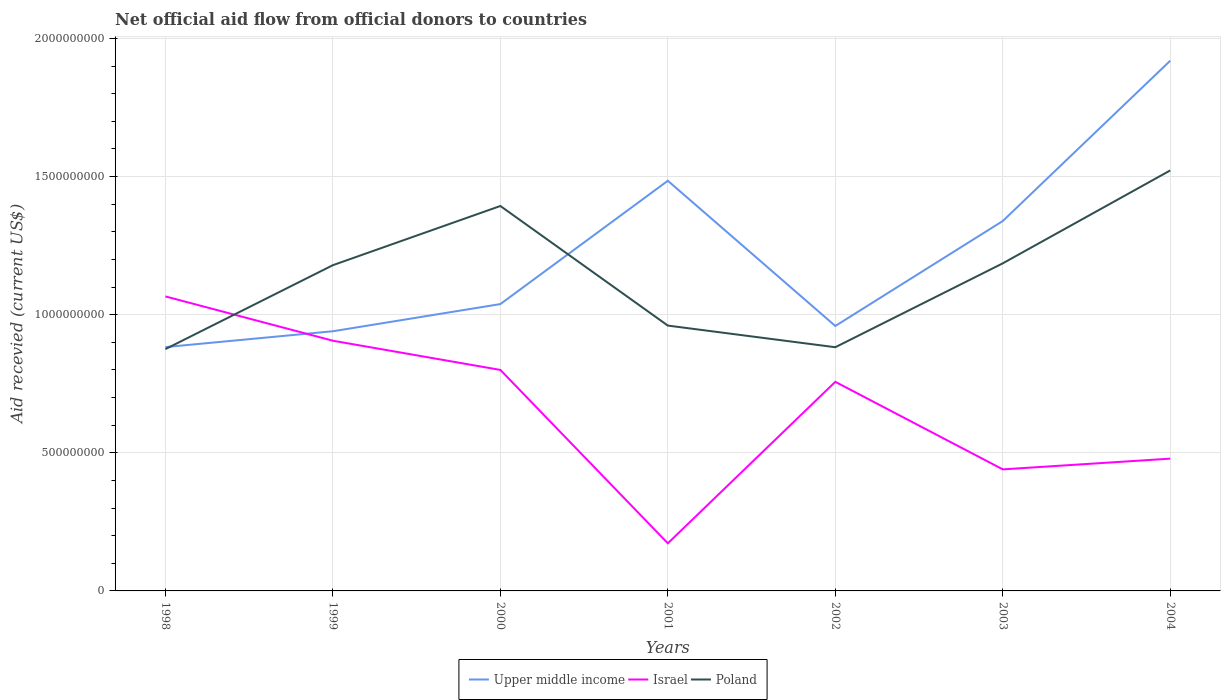Across all years, what is the maximum total aid received in Upper middle income?
Your answer should be very brief. 8.83e+08. What is the total total aid received in Upper middle income in the graph?
Provide a succinct answer. 1.46e+08. What is the difference between the highest and the second highest total aid received in Upper middle income?
Ensure brevity in your answer.  1.04e+09. Is the total aid received in Israel strictly greater than the total aid received in Upper middle income over the years?
Offer a terse response. No. What is the difference between two consecutive major ticks on the Y-axis?
Your response must be concise. 5.00e+08. Are the values on the major ticks of Y-axis written in scientific E-notation?
Make the answer very short. No. Does the graph contain grids?
Make the answer very short. Yes. Where does the legend appear in the graph?
Make the answer very short. Bottom center. How are the legend labels stacked?
Provide a short and direct response. Horizontal. What is the title of the graph?
Your answer should be very brief. Net official aid flow from official donors to countries. What is the label or title of the Y-axis?
Give a very brief answer. Aid recevied (current US$). What is the Aid recevied (current US$) in Upper middle income in 1998?
Your answer should be compact. 8.83e+08. What is the Aid recevied (current US$) of Israel in 1998?
Your response must be concise. 1.07e+09. What is the Aid recevied (current US$) in Poland in 1998?
Ensure brevity in your answer.  8.75e+08. What is the Aid recevied (current US$) in Upper middle income in 1999?
Give a very brief answer. 9.40e+08. What is the Aid recevied (current US$) of Israel in 1999?
Ensure brevity in your answer.  9.06e+08. What is the Aid recevied (current US$) in Poland in 1999?
Give a very brief answer. 1.18e+09. What is the Aid recevied (current US$) of Upper middle income in 2000?
Provide a short and direct response. 1.04e+09. What is the Aid recevied (current US$) of Israel in 2000?
Offer a terse response. 8.00e+08. What is the Aid recevied (current US$) of Poland in 2000?
Make the answer very short. 1.39e+09. What is the Aid recevied (current US$) in Upper middle income in 2001?
Your response must be concise. 1.48e+09. What is the Aid recevied (current US$) in Israel in 2001?
Provide a succinct answer. 1.72e+08. What is the Aid recevied (current US$) of Poland in 2001?
Make the answer very short. 9.60e+08. What is the Aid recevied (current US$) in Upper middle income in 2002?
Keep it short and to the point. 9.59e+08. What is the Aid recevied (current US$) in Israel in 2002?
Make the answer very short. 7.57e+08. What is the Aid recevied (current US$) in Poland in 2002?
Offer a very short reply. 8.82e+08. What is the Aid recevied (current US$) of Upper middle income in 2003?
Provide a succinct answer. 1.34e+09. What is the Aid recevied (current US$) in Israel in 2003?
Ensure brevity in your answer.  4.40e+08. What is the Aid recevied (current US$) in Poland in 2003?
Make the answer very short. 1.19e+09. What is the Aid recevied (current US$) of Upper middle income in 2004?
Make the answer very short. 1.92e+09. What is the Aid recevied (current US$) of Israel in 2004?
Your response must be concise. 4.79e+08. What is the Aid recevied (current US$) in Poland in 2004?
Offer a very short reply. 1.52e+09. Across all years, what is the maximum Aid recevied (current US$) in Upper middle income?
Provide a short and direct response. 1.92e+09. Across all years, what is the maximum Aid recevied (current US$) of Israel?
Your answer should be very brief. 1.07e+09. Across all years, what is the maximum Aid recevied (current US$) of Poland?
Offer a terse response. 1.52e+09. Across all years, what is the minimum Aid recevied (current US$) in Upper middle income?
Make the answer very short. 8.83e+08. Across all years, what is the minimum Aid recevied (current US$) of Israel?
Your answer should be very brief. 1.72e+08. Across all years, what is the minimum Aid recevied (current US$) in Poland?
Make the answer very short. 8.75e+08. What is the total Aid recevied (current US$) in Upper middle income in the graph?
Keep it short and to the point. 8.56e+09. What is the total Aid recevied (current US$) in Israel in the graph?
Your answer should be very brief. 4.62e+09. What is the total Aid recevied (current US$) in Poland in the graph?
Your response must be concise. 8.00e+09. What is the difference between the Aid recevied (current US$) in Upper middle income in 1998 and that in 1999?
Your answer should be very brief. -5.73e+07. What is the difference between the Aid recevied (current US$) in Israel in 1998 and that in 1999?
Offer a terse response. 1.60e+08. What is the difference between the Aid recevied (current US$) in Poland in 1998 and that in 1999?
Offer a terse response. -3.04e+08. What is the difference between the Aid recevied (current US$) of Upper middle income in 1998 and that in 2000?
Make the answer very short. -1.56e+08. What is the difference between the Aid recevied (current US$) of Israel in 1998 and that in 2000?
Keep it short and to the point. 2.66e+08. What is the difference between the Aid recevied (current US$) of Poland in 1998 and that in 2000?
Provide a short and direct response. -5.18e+08. What is the difference between the Aid recevied (current US$) in Upper middle income in 1998 and that in 2001?
Your response must be concise. -6.02e+08. What is the difference between the Aid recevied (current US$) in Israel in 1998 and that in 2001?
Ensure brevity in your answer.  8.94e+08. What is the difference between the Aid recevied (current US$) in Poland in 1998 and that in 2001?
Your answer should be compact. -8.51e+07. What is the difference between the Aid recevied (current US$) of Upper middle income in 1998 and that in 2002?
Ensure brevity in your answer.  -7.64e+07. What is the difference between the Aid recevied (current US$) of Israel in 1998 and that in 2002?
Your answer should be very brief. 3.09e+08. What is the difference between the Aid recevied (current US$) of Poland in 1998 and that in 2002?
Provide a succinct answer. -6.80e+06. What is the difference between the Aid recevied (current US$) of Upper middle income in 1998 and that in 2003?
Give a very brief answer. -4.56e+08. What is the difference between the Aid recevied (current US$) of Israel in 1998 and that in 2003?
Ensure brevity in your answer.  6.26e+08. What is the difference between the Aid recevied (current US$) of Poland in 1998 and that in 2003?
Offer a terse response. -3.11e+08. What is the difference between the Aid recevied (current US$) of Upper middle income in 1998 and that in 2004?
Your response must be concise. -1.04e+09. What is the difference between the Aid recevied (current US$) of Israel in 1998 and that in 2004?
Provide a short and direct response. 5.87e+08. What is the difference between the Aid recevied (current US$) of Poland in 1998 and that in 2004?
Offer a very short reply. -6.47e+08. What is the difference between the Aid recevied (current US$) in Upper middle income in 1999 and that in 2000?
Make the answer very short. -9.83e+07. What is the difference between the Aid recevied (current US$) of Israel in 1999 and that in 2000?
Offer a very short reply. 1.06e+08. What is the difference between the Aid recevied (current US$) in Poland in 1999 and that in 2000?
Your answer should be very brief. -2.14e+08. What is the difference between the Aid recevied (current US$) in Upper middle income in 1999 and that in 2001?
Provide a short and direct response. -5.45e+08. What is the difference between the Aid recevied (current US$) in Israel in 1999 and that in 2001?
Provide a short and direct response. 7.33e+08. What is the difference between the Aid recevied (current US$) in Poland in 1999 and that in 2001?
Your answer should be compact. 2.19e+08. What is the difference between the Aid recevied (current US$) in Upper middle income in 1999 and that in 2002?
Your answer should be compact. -1.91e+07. What is the difference between the Aid recevied (current US$) of Israel in 1999 and that in 2002?
Provide a succinct answer. 1.49e+08. What is the difference between the Aid recevied (current US$) of Poland in 1999 and that in 2002?
Keep it short and to the point. 2.97e+08. What is the difference between the Aid recevied (current US$) in Upper middle income in 1999 and that in 2003?
Make the answer very short. -3.99e+08. What is the difference between the Aid recevied (current US$) in Israel in 1999 and that in 2003?
Offer a very short reply. 4.66e+08. What is the difference between the Aid recevied (current US$) in Poland in 1999 and that in 2003?
Your response must be concise. -6.69e+06. What is the difference between the Aid recevied (current US$) in Upper middle income in 1999 and that in 2004?
Give a very brief answer. -9.79e+08. What is the difference between the Aid recevied (current US$) of Israel in 1999 and that in 2004?
Offer a very short reply. 4.27e+08. What is the difference between the Aid recevied (current US$) of Poland in 1999 and that in 2004?
Ensure brevity in your answer.  -3.43e+08. What is the difference between the Aid recevied (current US$) of Upper middle income in 2000 and that in 2001?
Offer a terse response. -4.46e+08. What is the difference between the Aid recevied (current US$) in Israel in 2000 and that in 2001?
Provide a short and direct response. 6.28e+08. What is the difference between the Aid recevied (current US$) in Poland in 2000 and that in 2001?
Your response must be concise. 4.33e+08. What is the difference between the Aid recevied (current US$) of Upper middle income in 2000 and that in 2002?
Provide a short and direct response. 7.93e+07. What is the difference between the Aid recevied (current US$) in Israel in 2000 and that in 2002?
Provide a short and direct response. 4.31e+07. What is the difference between the Aid recevied (current US$) of Poland in 2000 and that in 2002?
Provide a short and direct response. 5.11e+08. What is the difference between the Aid recevied (current US$) of Upper middle income in 2000 and that in 2003?
Your answer should be compact. -3.01e+08. What is the difference between the Aid recevied (current US$) of Israel in 2000 and that in 2003?
Your answer should be compact. 3.60e+08. What is the difference between the Aid recevied (current US$) in Poland in 2000 and that in 2003?
Ensure brevity in your answer.  2.08e+08. What is the difference between the Aid recevied (current US$) in Upper middle income in 2000 and that in 2004?
Offer a very short reply. -8.81e+08. What is the difference between the Aid recevied (current US$) in Israel in 2000 and that in 2004?
Your answer should be very brief. 3.21e+08. What is the difference between the Aid recevied (current US$) of Poland in 2000 and that in 2004?
Your answer should be compact. -1.29e+08. What is the difference between the Aid recevied (current US$) of Upper middle income in 2001 and that in 2002?
Offer a very short reply. 5.26e+08. What is the difference between the Aid recevied (current US$) in Israel in 2001 and that in 2002?
Keep it short and to the point. -5.85e+08. What is the difference between the Aid recevied (current US$) in Poland in 2001 and that in 2002?
Your answer should be compact. 7.83e+07. What is the difference between the Aid recevied (current US$) of Upper middle income in 2001 and that in 2003?
Ensure brevity in your answer.  1.46e+08. What is the difference between the Aid recevied (current US$) in Israel in 2001 and that in 2003?
Keep it short and to the point. -2.68e+08. What is the difference between the Aid recevied (current US$) in Poland in 2001 and that in 2003?
Ensure brevity in your answer.  -2.25e+08. What is the difference between the Aid recevied (current US$) of Upper middle income in 2001 and that in 2004?
Provide a short and direct response. -4.35e+08. What is the difference between the Aid recevied (current US$) of Israel in 2001 and that in 2004?
Give a very brief answer. -3.06e+08. What is the difference between the Aid recevied (current US$) in Poland in 2001 and that in 2004?
Your answer should be compact. -5.62e+08. What is the difference between the Aid recevied (current US$) of Upper middle income in 2002 and that in 2003?
Keep it short and to the point. -3.80e+08. What is the difference between the Aid recevied (current US$) in Israel in 2002 and that in 2003?
Your answer should be compact. 3.17e+08. What is the difference between the Aid recevied (current US$) in Poland in 2002 and that in 2003?
Offer a terse response. -3.04e+08. What is the difference between the Aid recevied (current US$) in Upper middle income in 2002 and that in 2004?
Your answer should be very brief. -9.60e+08. What is the difference between the Aid recevied (current US$) in Israel in 2002 and that in 2004?
Offer a terse response. 2.78e+08. What is the difference between the Aid recevied (current US$) of Poland in 2002 and that in 2004?
Offer a very short reply. -6.40e+08. What is the difference between the Aid recevied (current US$) in Upper middle income in 2003 and that in 2004?
Make the answer very short. -5.80e+08. What is the difference between the Aid recevied (current US$) of Israel in 2003 and that in 2004?
Give a very brief answer. -3.89e+07. What is the difference between the Aid recevied (current US$) in Poland in 2003 and that in 2004?
Make the answer very short. -3.36e+08. What is the difference between the Aid recevied (current US$) in Upper middle income in 1998 and the Aid recevied (current US$) in Israel in 1999?
Provide a short and direct response. -2.31e+07. What is the difference between the Aid recevied (current US$) in Upper middle income in 1998 and the Aid recevied (current US$) in Poland in 1999?
Offer a terse response. -2.96e+08. What is the difference between the Aid recevied (current US$) of Israel in 1998 and the Aid recevied (current US$) of Poland in 1999?
Provide a succinct answer. -1.13e+08. What is the difference between the Aid recevied (current US$) in Upper middle income in 1998 and the Aid recevied (current US$) in Israel in 2000?
Make the answer very short. 8.26e+07. What is the difference between the Aid recevied (current US$) in Upper middle income in 1998 and the Aid recevied (current US$) in Poland in 2000?
Your answer should be compact. -5.11e+08. What is the difference between the Aid recevied (current US$) of Israel in 1998 and the Aid recevied (current US$) of Poland in 2000?
Provide a short and direct response. -3.27e+08. What is the difference between the Aid recevied (current US$) in Upper middle income in 1998 and the Aid recevied (current US$) in Israel in 2001?
Give a very brief answer. 7.10e+08. What is the difference between the Aid recevied (current US$) in Upper middle income in 1998 and the Aid recevied (current US$) in Poland in 2001?
Your answer should be very brief. -7.78e+07. What is the difference between the Aid recevied (current US$) of Israel in 1998 and the Aid recevied (current US$) of Poland in 2001?
Your answer should be compact. 1.06e+08. What is the difference between the Aid recevied (current US$) of Upper middle income in 1998 and the Aid recevied (current US$) of Israel in 2002?
Provide a succinct answer. 1.26e+08. What is the difference between the Aid recevied (current US$) in Upper middle income in 1998 and the Aid recevied (current US$) in Poland in 2002?
Your answer should be very brief. 5.20e+05. What is the difference between the Aid recevied (current US$) of Israel in 1998 and the Aid recevied (current US$) of Poland in 2002?
Offer a terse response. 1.84e+08. What is the difference between the Aid recevied (current US$) in Upper middle income in 1998 and the Aid recevied (current US$) in Israel in 2003?
Offer a very short reply. 4.43e+08. What is the difference between the Aid recevied (current US$) in Upper middle income in 1998 and the Aid recevied (current US$) in Poland in 2003?
Give a very brief answer. -3.03e+08. What is the difference between the Aid recevied (current US$) of Israel in 1998 and the Aid recevied (current US$) of Poland in 2003?
Provide a succinct answer. -1.20e+08. What is the difference between the Aid recevied (current US$) of Upper middle income in 1998 and the Aid recevied (current US$) of Israel in 2004?
Your answer should be very brief. 4.04e+08. What is the difference between the Aid recevied (current US$) in Upper middle income in 1998 and the Aid recevied (current US$) in Poland in 2004?
Your answer should be very brief. -6.40e+08. What is the difference between the Aid recevied (current US$) in Israel in 1998 and the Aid recevied (current US$) in Poland in 2004?
Ensure brevity in your answer.  -4.56e+08. What is the difference between the Aid recevied (current US$) in Upper middle income in 1999 and the Aid recevied (current US$) in Israel in 2000?
Keep it short and to the point. 1.40e+08. What is the difference between the Aid recevied (current US$) of Upper middle income in 1999 and the Aid recevied (current US$) of Poland in 2000?
Give a very brief answer. -4.53e+08. What is the difference between the Aid recevied (current US$) in Israel in 1999 and the Aid recevied (current US$) in Poland in 2000?
Offer a very short reply. -4.88e+08. What is the difference between the Aid recevied (current US$) of Upper middle income in 1999 and the Aid recevied (current US$) of Israel in 2001?
Make the answer very short. 7.68e+08. What is the difference between the Aid recevied (current US$) of Upper middle income in 1999 and the Aid recevied (current US$) of Poland in 2001?
Keep it short and to the point. -2.05e+07. What is the difference between the Aid recevied (current US$) of Israel in 1999 and the Aid recevied (current US$) of Poland in 2001?
Provide a short and direct response. -5.48e+07. What is the difference between the Aid recevied (current US$) of Upper middle income in 1999 and the Aid recevied (current US$) of Israel in 2002?
Offer a terse response. 1.83e+08. What is the difference between the Aid recevied (current US$) of Upper middle income in 1999 and the Aid recevied (current US$) of Poland in 2002?
Provide a short and direct response. 5.78e+07. What is the difference between the Aid recevied (current US$) of Israel in 1999 and the Aid recevied (current US$) of Poland in 2002?
Make the answer very short. 2.36e+07. What is the difference between the Aid recevied (current US$) in Upper middle income in 1999 and the Aid recevied (current US$) in Israel in 2003?
Your answer should be very brief. 5.00e+08. What is the difference between the Aid recevied (current US$) of Upper middle income in 1999 and the Aid recevied (current US$) of Poland in 2003?
Your answer should be compact. -2.46e+08. What is the difference between the Aid recevied (current US$) in Israel in 1999 and the Aid recevied (current US$) in Poland in 2003?
Offer a terse response. -2.80e+08. What is the difference between the Aid recevied (current US$) in Upper middle income in 1999 and the Aid recevied (current US$) in Israel in 2004?
Offer a terse response. 4.61e+08. What is the difference between the Aid recevied (current US$) in Upper middle income in 1999 and the Aid recevied (current US$) in Poland in 2004?
Offer a very short reply. -5.82e+08. What is the difference between the Aid recevied (current US$) of Israel in 1999 and the Aid recevied (current US$) of Poland in 2004?
Provide a succinct answer. -6.16e+08. What is the difference between the Aid recevied (current US$) in Upper middle income in 2000 and the Aid recevied (current US$) in Israel in 2001?
Give a very brief answer. 8.66e+08. What is the difference between the Aid recevied (current US$) in Upper middle income in 2000 and the Aid recevied (current US$) in Poland in 2001?
Your response must be concise. 7.78e+07. What is the difference between the Aid recevied (current US$) of Israel in 2000 and the Aid recevied (current US$) of Poland in 2001?
Your response must be concise. -1.60e+08. What is the difference between the Aid recevied (current US$) in Upper middle income in 2000 and the Aid recevied (current US$) in Israel in 2002?
Ensure brevity in your answer.  2.81e+08. What is the difference between the Aid recevied (current US$) in Upper middle income in 2000 and the Aid recevied (current US$) in Poland in 2002?
Your answer should be compact. 1.56e+08. What is the difference between the Aid recevied (current US$) of Israel in 2000 and the Aid recevied (current US$) of Poland in 2002?
Offer a very short reply. -8.21e+07. What is the difference between the Aid recevied (current US$) in Upper middle income in 2000 and the Aid recevied (current US$) in Israel in 2003?
Your response must be concise. 5.98e+08. What is the difference between the Aid recevied (current US$) of Upper middle income in 2000 and the Aid recevied (current US$) of Poland in 2003?
Give a very brief answer. -1.48e+08. What is the difference between the Aid recevied (current US$) in Israel in 2000 and the Aid recevied (current US$) in Poland in 2003?
Ensure brevity in your answer.  -3.86e+08. What is the difference between the Aid recevied (current US$) in Upper middle income in 2000 and the Aid recevied (current US$) in Israel in 2004?
Give a very brief answer. 5.59e+08. What is the difference between the Aid recevied (current US$) of Upper middle income in 2000 and the Aid recevied (current US$) of Poland in 2004?
Offer a very short reply. -4.84e+08. What is the difference between the Aid recevied (current US$) of Israel in 2000 and the Aid recevied (current US$) of Poland in 2004?
Make the answer very short. -7.22e+08. What is the difference between the Aid recevied (current US$) of Upper middle income in 2001 and the Aid recevied (current US$) of Israel in 2002?
Give a very brief answer. 7.28e+08. What is the difference between the Aid recevied (current US$) of Upper middle income in 2001 and the Aid recevied (current US$) of Poland in 2002?
Your response must be concise. 6.03e+08. What is the difference between the Aid recevied (current US$) in Israel in 2001 and the Aid recevied (current US$) in Poland in 2002?
Ensure brevity in your answer.  -7.10e+08. What is the difference between the Aid recevied (current US$) in Upper middle income in 2001 and the Aid recevied (current US$) in Israel in 2003?
Your answer should be very brief. 1.04e+09. What is the difference between the Aid recevied (current US$) in Upper middle income in 2001 and the Aid recevied (current US$) in Poland in 2003?
Provide a succinct answer. 2.99e+08. What is the difference between the Aid recevied (current US$) of Israel in 2001 and the Aid recevied (current US$) of Poland in 2003?
Your answer should be very brief. -1.01e+09. What is the difference between the Aid recevied (current US$) of Upper middle income in 2001 and the Aid recevied (current US$) of Israel in 2004?
Offer a very short reply. 1.01e+09. What is the difference between the Aid recevied (current US$) in Upper middle income in 2001 and the Aid recevied (current US$) in Poland in 2004?
Keep it short and to the point. -3.74e+07. What is the difference between the Aid recevied (current US$) of Israel in 2001 and the Aid recevied (current US$) of Poland in 2004?
Your answer should be compact. -1.35e+09. What is the difference between the Aid recevied (current US$) in Upper middle income in 2002 and the Aid recevied (current US$) in Israel in 2003?
Offer a very short reply. 5.19e+08. What is the difference between the Aid recevied (current US$) in Upper middle income in 2002 and the Aid recevied (current US$) in Poland in 2003?
Keep it short and to the point. -2.27e+08. What is the difference between the Aid recevied (current US$) in Israel in 2002 and the Aid recevied (current US$) in Poland in 2003?
Offer a very short reply. -4.29e+08. What is the difference between the Aid recevied (current US$) in Upper middle income in 2002 and the Aid recevied (current US$) in Israel in 2004?
Offer a very short reply. 4.80e+08. What is the difference between the Aid recevied (current US$) of Upper middle income in 2002 and the Aid recevied (current US$) of Poland in 2004?
Ensure brevity in your answer.  -5.63e+08. What is the difference between the Aid recevied (current US$) in Israel in 2002 and the Aid recevied (current US$) in Poland in 2004?
Keep it short and to the point. -7.65e+08. What is the difference between the Aid recevied (current US$) of Upper middle income in 2003 and the Aid recevied (current US$) of Israel in 2004?
Provide a succinct answer. 8.60e+08. What is the difference between the Aid recevied (current US$) in Upper middle income in 2003 and the Aid recevied (current US$) in Poland in 2004?
Your answer should be very brief. -1.83e+08. What is the difference between the Aid recevied (current US$) of Israel in 2003 and the Aid recevied (current US$) of Poland in 2004?
Your answer should be very brief. -1.08e+09. What is the average Aid recevied (current US$) in Upper middle income per year?
Provide a succinct answer. 1.22e+09. What is the average Aid recevied (current US$) of Israel per year?
Ensure brevity in your answer.  6.60e+08. What is the average Aid recevied (current US$) in Poland per year?
Ensure brevity in your answer.  1.14e+09. In the year 1998, what is the difference between the Aid recevied (current US$) of Upper middle income and Aid recevied (current US$) of Israel?
Your response must be concise. -1.83e+08. In the year 1998, what is the difference between the Aid recevied (current US$) of Upper middle income and Aid recevied (current US$) of Poland?
Provide a short and direct response. 7.32e+06. In the year 1998, what is the difference between the Aid recevied (current US$) in Israel and Aid recevied (current US$) in Poland?
Keep it short and to the point. 1.91e+08. In the year 1999, what is the difference between the Aid recevied (current US$) of Upper middle income and Aid recevied (current US$) of Israel?
Provide a succinct answer. 3.43e+07. In the year 1999, what is the difference between the Aid recevied (current US$) in Upper middle income and Aid recevied (current US$) in Poland?
Offer a very short reply. -2.39e+08. In the year 1999, what is the difference between the Aid recevied (current US$) in Israel and Aid recevied (current US$) in Poland?
Your answer should be very brief. -2.73e+08. In the year 2000, what is the difference between the Aid recevied (current US$) in Upper middle income and Aid recevied (current US$) in Israel?
Offer a terse response. 2.38e+08. In the year 2000, what is the difference between the Aid recevied (current US$) of Upper middle income and Aid recevied (current US$) of Poland?
Your answer should be very brief. -3.55e+08. In the year 2000, what is the difference between the Aid recevied (current US$) of Israel and Aid recevied (current US$) of Poland?
Your answer should be very brief. -5.93e+08. In the year 2001, what is the difference between the Aid recevied (current US$) in Upper middle income and Aid recevied (current US$) in Israel?
Make the answer very short. 1.31e+09. In the year 2001, what is the difference between the Aid recevied (current US$) in Upper middle income and Aid recevied (current US$) in Poland?
Your answer should be compact. 5.24e+08. In the year 2001, what is the difference between the Aid recevied (current US$) of Israel and Aid recevied (current US$) of Poland?
Make the answer very short. -7.88e+08. In the year 2002, what is the difference between the Aid recevied (current US$) in Upper middle income and Aid recevied (current US$) in Israel?
Offer a terse response. 2.02e+08. In the year 2002, what is the difference between the Aid recevied (current US$) of Upper middle income and Aid recevied (current US$) of Poland?
Your answer should be compact. 7.69e+07. In the year 2002, what is the difference between the Aid recevied (current US$) of Israel and Aid recevied (current US$) of Poland?
Your response must be concise. -1.25e+08. In the year 2003, what is the difference between the Aid recevied (current US$) of Upper middle income and Aid recevied (current US$) of Israel?
Offer a terse response. 8.99e+08. In the year 2003, what is the difference between the Aid recevied (current US$) of Upper middle income and Aid recevied (current US$) of Poland?
Ensure brevity in your answer.  1.53e+08. In the year 2003, what is the difference between the Aid recevied (current US$) of Israel and Aid recevied (current US$) of Poland?
Offer a terse response. -7.46e+08. In the year 2004, what is the difference between the Aid recevied (current US$) of Upper middle income and Aid recevied (current US$) of Israel?
Offer a very short reply. 1.44e+09. In the year 2004, what is the difference between the Aid recevied (current US$) in Upper middle income and Aid recevied (current US$) in Poland?
Make the answer very short. 3.97e+08. In the year 2004, what is the difference between the Aid recevied (current US$) in Israel and Aid recevied (current US$) in Poland?
Offer a terse response. -1.04e+09. What is the ratio of the Aid recevied (current US$) in Upper middle income in 1998 to that in 1999?
Provide a succinct answer. 0.94. What is the ratio of the Aid recevied (current US$) of Israel in 1998 to that in 1999?
Offer a terse response. 1.18. What is the ratio of the Aid recevied (current US$) of Poland in 1998 to that in 1999?
Give a very brief answer. 0.74. What is the ratio of the Aid recevied (current US$) of Upper middle income in 1998 to that in 2000?
Provide a short and direct response. 0.85. What is the ratio of the Aid recevied (current US$) in Israel in 1998 to that in 2000?
Offer a very short reply. 1.33. What is the ratio of the Aid recevied (current US$) of Poland in 1998 to that in 2000?
Provide a short and direct response. 0.63. What is the ratio of the Aid recevied (current US$) in Upper middle income in 1998 to that in 2001?
Provide a succinct answer. 0.59. What is the ratio of the Aid recevied (current US$) of Israel in 1998 to that in 2001?
Your answer should be compact. 6.19. What is the ratio of the Aid recevied (current US$) in Poland in 1998 to that in 2001?
Provide a short and direct response. 0.91. What is the ratio of the Aid recevied (current US$) in Upper middle income in 1998 to that in 2002?
Your answer should be compact. 0.92. What is the ratio of the Aid recevied (current US$) of Israel in 1998 to that in 2002?
Ensure brevity in your answer.  1.41. What is the ratio of the Aid recevied (current US$) in Poland in 1998 to that in 2002?
Your answer should be compact. 0.99. What is the ratio of the Aid recevied (current US$) in Upper middle income in 1998 to that in 2003?
Make the answer very short. 0.66. What is the ratio of the Aid recevied (current US$) of Israel in 1998 to that in 2003?
Your answer should be very brief. 2.42. What is the ratio of the Aid recevied (current US$) in Poland in 1998 to that in 2003?
Keep it short and to the point. 0.74. What is the ratio of the Aid recevied (current US$) of Upper middle income in 1998 to that in 2004?
Your response must be concise. 0.46. What is the ratio of the Aid recevied (current US$) of Israel in 1998 to that in 2004?
Provide a succinct answer. 2.23. What is the ratio of the Aid recevied (current US$) in Poland in 1998 to that in 2004?
Make the answer very short. 0.58. What is the ratio of the Aid recevied (current US$) of Upper middle income in 1999 to that in 2000?
Provide a short and direct response. 0.91. What is the ratio of the Aid recevied (current US$) of Israel in 1999 to that in 2000?
Offer a terse response. 1.13. What is the ratio of the Aid recevied (current US$) in Poland in 1999 to that in 2000?
Make the answer very short. 0.85. What is the ratio of the Aid recevied (current US$) in Upper middle income in 1999 to that in 2001?
Your answer should be compact. 0.63. What is the ratio of the Aid recevied (current US$) in Israel in 1999 to that in 2001?
Your answer should be very brief. 5.26. What is the ratio of the Aid recevied (current US$) in Poland in 1999 to that in 2001?
Your answer should be compact. 1.23. What is the ratio of the Aid recevied (current US$) in Upper middle income in 1999 to that in 2002?
Offer a terse response. 0.98. What is the ratio of the Aid recevied (current US$) in Israel in 1999 to that in 2002?
Ensure brevity in your answer.  1.2. What is the ratio of the Aid recevied (current US$) of Poland in 1999 to that in 2002?
Give a very brief answer. 1.34. What is the ratio of the Aid recevied (current US$) of Upper middle income in 1999 to that in 2003?
Provide a succinct answer. 0.7. What is the ratio of the Aid recevied (current US$) in Israel in 1999 to that in 2003?
Provide a short and direct response. 2.06. What is the ratio of the Aid recevied (current US$) in Upper middle income in 1999 to that in 2004?
Keep it short and to the point. 0.49. What is the ratio of the Aid recevied (current US$) in Israel in 1999 to that in 2004?
Provide a succinct answer. 1.89. What is the ratio of the Aid recevied (current US$) in Poland in 1999 to that in 2004?
Your answer should be compact. 0.77. What is the ratio of the Aid recevied (current US$) of Upper middle income in 2000 to that in 2001?
Provide a succinct answer. 0.7. What is the ratio of the Aid recevied (current US$) in Israel in 2000 to that in 2001?
Provide a succinct answer. 4.64. What is the ratio of the Aid recevied (current US$) of Poland in 2000 to that in 2001?
Your answer should be very brief. 1.45. What is the ratio of the Aid recevied (current US$) of Upper middle income in 2000 to that in 2002?
Offer a very short reply. 1.08. What is the ratio of the Aid recevied (current US$) of Israel in 2000 to that in 2002?
Give a very brief answer. 1.06. What is the ratio of the Aid recevied (current US$) of Poland in 2000 to that in 2002?
Offer a very short reply. 1.58. What is the ratio of the Aid recevied (current US$) in Upper middle income in 2000 to that in 2003?
Ensure brevity in your answer.  0.78. What is the ratio of the Aid recevied (current US$) in Israel in 2000 to that in 2003?
Offer a terse response. 1.82. What is the ratio of the Aid recevied (current US$) of Poland in 2000 to that in 2003?
Your answer should be compact. 1.18. What is the ratio of the Aid recevied (current US$) in Upper middle income in 2000 to that in 2004?
Offer a terse response. 0.54. What is the ratio of the Aid recevied (current US$) in Israel in 2000 to that in 2004?
Your response must be concise. 1.67. What is the ratio of the Aid recevied (current US$) in Poland in 2000 to that in 2004?
Your response must be concise. 0.92. What is the ratio of the Aid recevied (current US$) of Upper middle income in 2001 to that in 2002?
Give a very brief answer. 1.55. What is the ratio of the Aid recevied (current US$) of Israel in 2001 to that in 2002?
Provide a succinct answer. 0.23. What is the ratio of the Aid recevied (current US$) in Poland in 2001 to that in 2002?
Make the answer very short. 1.09. What is the ratio of the Aid recevied (current US$) in Upper middle income in 2001 to that in 2003?
Provide a succinct answer. 1.11. What is the ratio of the Aid recevied (current US$) in Israel in 2001 to that in 2003?
Your answer should be very brief. 0.39. What is the ratio of the Aid recevied (current US$) of Poland in 2001 to that in 2003?
Your answer should be very brief. 0.81. What is the ratio of the Aid recevied (current US$) in Upper middle income in 2001 to that in 2004?
Offer a very short reply. 0.77. What is the ratio of the Aid recevied (current US$) of Israel in 2001 to that in 2004?
Your response must be concise. 0.36. What is the ratio of the Aid recevied (current US$) of Poland in 2001 to that in 2004?
Your answer should be very brief. 0.63. What is the ratio of the Aid recevied (current US$) of Upper middle income in 2002 to that in 2003?
Make the answer very short. 0.72. What is the ratio of the Aid recevied (current US$) of Israel in 2002 to that in 2003?
Provide a short and direct response. 1.72. What is the ratio of the Aid recevied (current US$) of Poland in 2002 to that in 2003?
Ensure brevity in your answer.  0.74. What is the ratio of the Aid recevied (current US$) in Upper middle income in 2002 to that in 2004?
Your answer should be compact. 0.5. What is the ratio of the Aid recevied (current US$) of Israel in 2002 to that in 2004?
Ensure brevity in your answer.  1.58. What is the ratio of the Aid recevied (current US$) in Poland in 2002 to that in 2004?
Your response must be concise. 0.58. What is the ratio of the Aid recevied (current US$) of Upper middle income in 2003 to that in 2004?
Offer a very short reply. 0.7. What is the ratio of the Aid recevied (current US$) of Israel in 2003 to that in 2004?
Offer a terse response. 0.92. What is the ratio of the Aid recevied (current US$) of Poland in 2003 to that in 2004?
Provide a succinct answer. 0.78. What is the difference between the highest and the second highest Aid recevied (current US$) in Upper middle income?
Your response must be concise. 4.35e+08. What is the difference between the highest and the second highest Aid recevied (current US$) of Israel?
Your response must be concise. 1.60e+08. What is the difference between the highest and the second highest Aid recevied (current US$) of Poland?
Make the answer very short. 1.29e+08. What is the difference between the highest and the lowest Aid recevied (current US$) of Upper middle income?
Your response must be concise. 1.04e+09. What is the difference between the highest and the lowest Aid recevied (current US$) in Israel?
Your response must be concise. 8.94e+08. What is the difference between the highest and the lowest Aid recevied (current US$) in Poland?
Your answer should be very brief. 6.47e+08. 